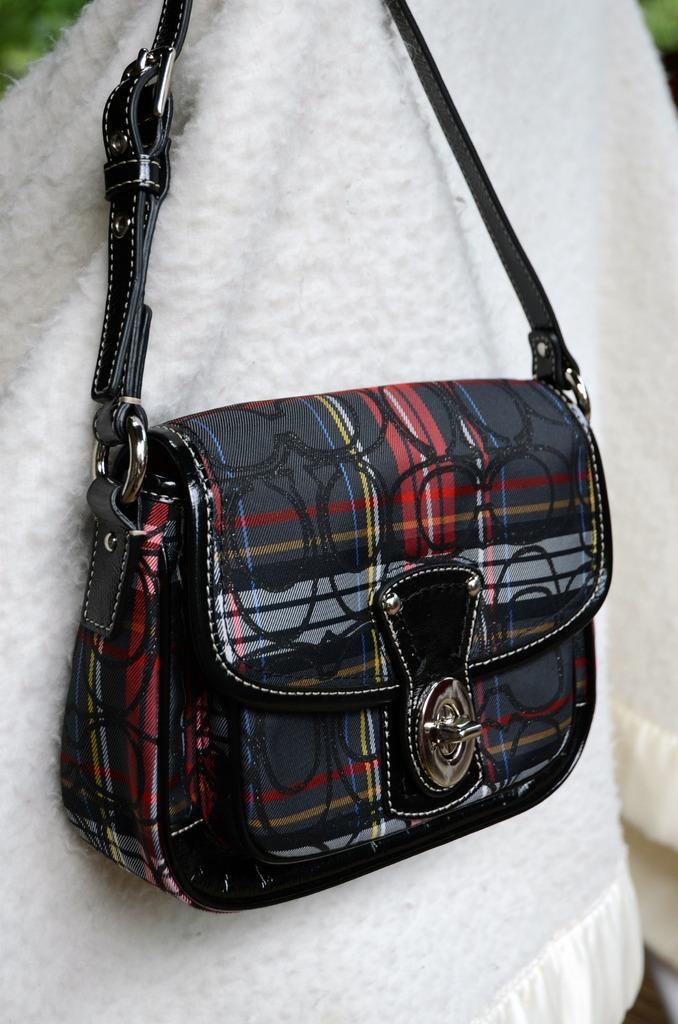How would you summarize this image in a sentence or two? There is a multi color bag ,which is kept on a white color cloth, the handle of the bag is black color. 